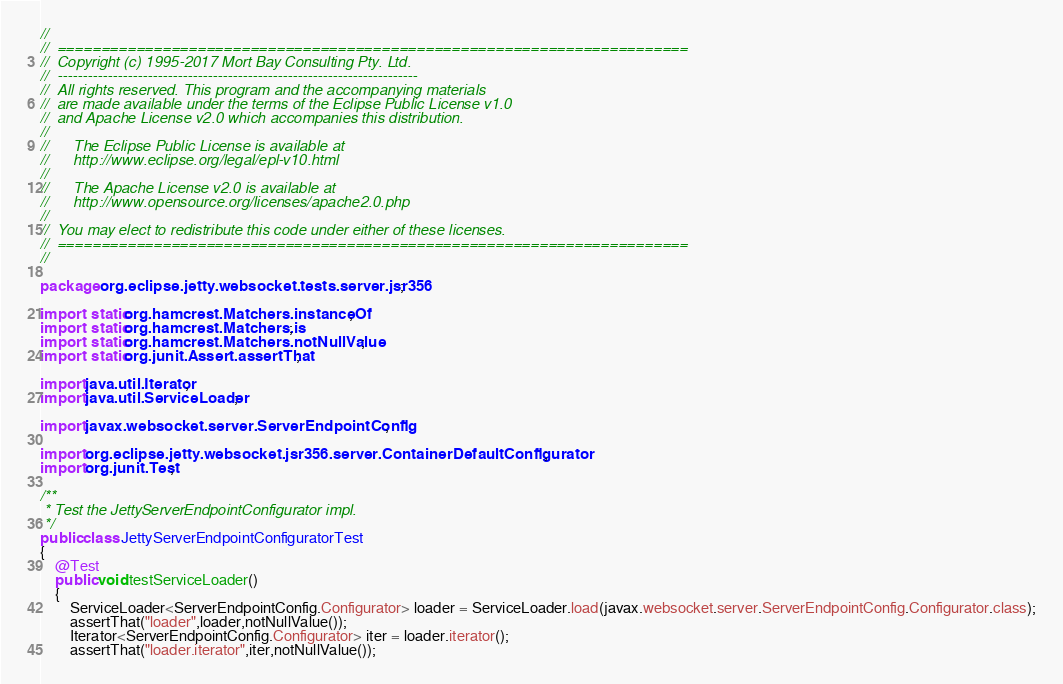Convert code to text. <code><loc_0><loc_0><loc_500><loc_500><_Java_>//
//  ========================================================================
//  Copyright (c) 1995-2017 Mort Bay Consulting Pty. Ltd.
//  ------------------------------------------------------------------------
//  All rights reserved. This program and the accompanying materials
//  are made available under the terms of the Eclipse Public License v1.0
//  and Apache License v2.0 which accompanies this distribution.
//
//      The Eclipse Public License is available at
//      http://www.eclipse.org/legal/epl-v10.html
//
//      The Apache License v2.0 is available at
//      http://www.opensource.org/licenses/apache2.0.php
//
//  You may elect to redistribute this code under either of these licenses.
//  ========================================================================
//

package org.eclipse.jetty.websocket.tests.server.jsr356;

import static org.hamcrest.Matchers.instanceOf;
import static org.hamcrest.Matchers.is;
import static org.hamcrest.Matchers.notNullValue;
import static org.junit.Assert.assertThat;

import java.util.Iterator;
import java.util.ServiceLoader;

import javax.websocket.server.ServerEndpointConfig;

import org.eclipse.jetty.websocket.jsr356.server.ContainerDefaultConfigurator;
import org.junit.Test;

/**
 * Test the JettyServerEndpointConfigurator impl.
 */
public class JettyServerEndpointConfiguratorTest
{
    @Test
    public void testServiceLoader()
    {
        ServiceLoader<ServerEndpointConfig.Configurator> loader = ServiceLoader.load(javax.websocket.server.ServerEndpointConfig.Configurator.class);
        assertThat("loader",loader,notNullValue());
        Iterator<ServerEndpointConfig.Configurator> iter = loader.iterator();
        assertThat("loader.iterator",iter,notNullValue());</code> 